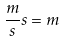Convert formula to latex. <formula><loc_0><loc_0><loc_500><loc_500>\frac { m } { s } s = m</formula> 